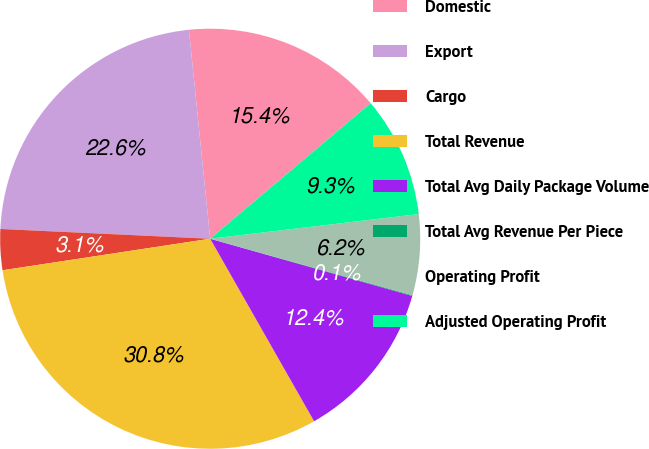Convert chart. <chart><loc_0><loc_0><loc_500><loc_500><pie_chart><fcel>Domestic<fcel>Export<fcel>Cargo<fcel>Total Revenue<fcel>Total Avg Daily Package Volume<fcel>Total Avg Revenue Per Piece<fcel>Operating Profit<fcel>Adjusted Operating Profit<nl><fcel>15.45%<fcel>22.65%<fcel>3.14%<fcel>30.84%<fcel>12.37%<fcel>0.06%<fcel>6.21%<fcel>9.29%<nl></chart> 